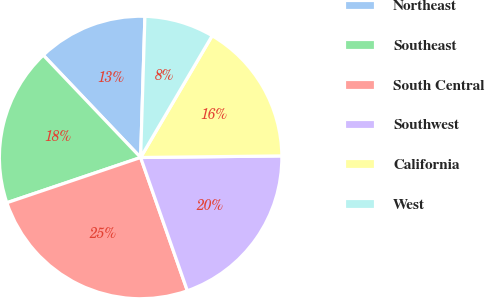<chart> <loc_0><loc_0><loc_500><loc_500><pie_chart><fcel>Northeast<fcel>Southeast<fcel>South Central<fcel>Southwest<fcel>California<fcel>West<nl><fcel>12.59%<fcel>18.09%<fcel>25.18%<fcel>19.81%<fcel>16.37%<fcel>7.97%<nl></chart> 